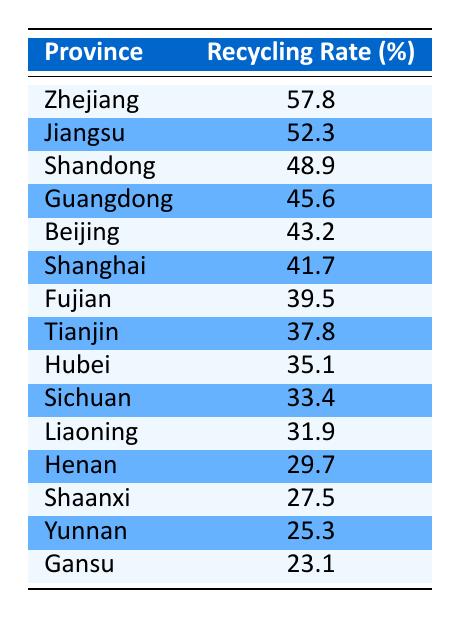What is the recycling rate in Zhejiang? The table lists a recycling rate of 57.8% for the province of Zhejiang.
Answer: 57.8% Which province has the lowest recycling rate? The lowest recycling rate is found in Gansu, with a rate of 23.1%.
Answer: Gansu What is the average recycling rate of the top three provinces? The top three provinces by recycling rate are Zhejiang (57.8%), Jiangsu (52.3%), and Shandong (48.9%). The sum of these rates is 57.8 + 52.3 + 48.9 = 158.9. To find the average, divide by 3: 158.9 / 3 ≈ 52.97.
Answer: Approximately 52.97% Is the recycling rate in Beijing higher than that in Guangdong? The recycling rate in Beijing is 43.2%, while in Guangdong, it is 45.6%. Since 43.2 is not greater than 45.6, the statement is false.
Answer: No How much higher is the recycling rate in Jiangsu compared to Gansu? The recycling rate in Jiangsu is 52.3%, and the rate in Gansu is 23.1%. To find the difference, subtract: 52.3 - 23.1 = 29.2.
Answer: 29.2% 